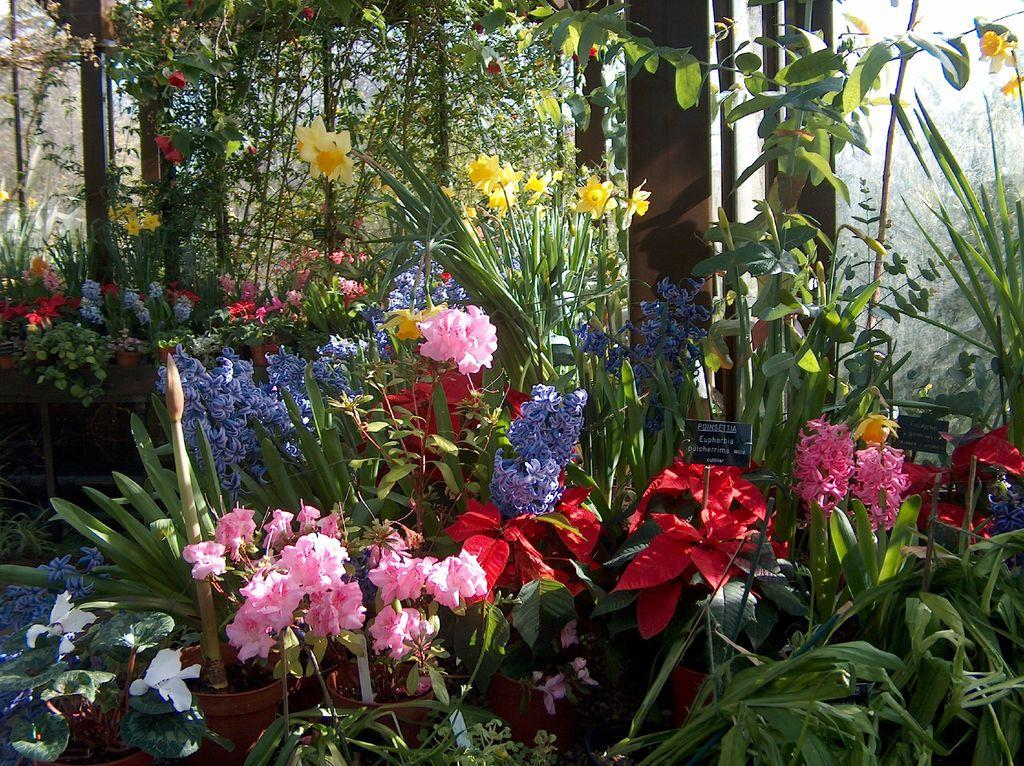What types of vegetation can be seen in the front of the image? There are plants and flowers in the front of the image. What can be seen in the background of the image? There are trees in the background of the image. Where are the name tags located in the image? The name tags are present on the right side of the image. How much money is being displayed in the image? There is no money present in the image; it features plants, flowers, trees, and name tags. What type of army can be seen in the image? There is no army present in the image; it features plants, flowers, trees, and name tags. 